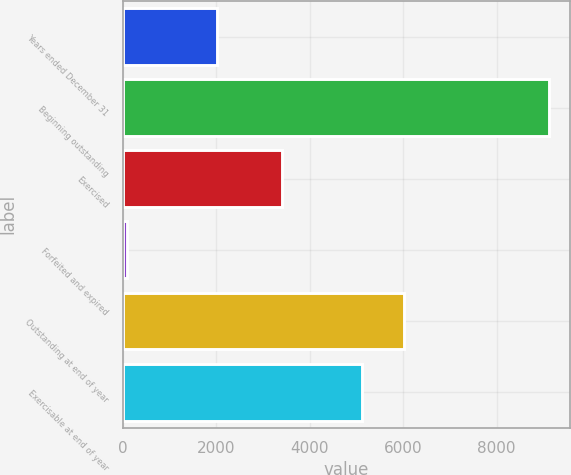Convert chart to OTSL. <chart><loc_0><loc_0><loc_500><loc_500><bar_chart><fcel>Years ended December 31<fcel>Beginning outstanding<fcel>Exercised<fcel>Forfeited and expired<fcel>Outstanding at end of year<fcel>Exercisable at end of year<nl><fcel>2012<fcel>9116<fcel>3413<fcel>92<fcel>6019.4<fcel>5117<nl></chart> 